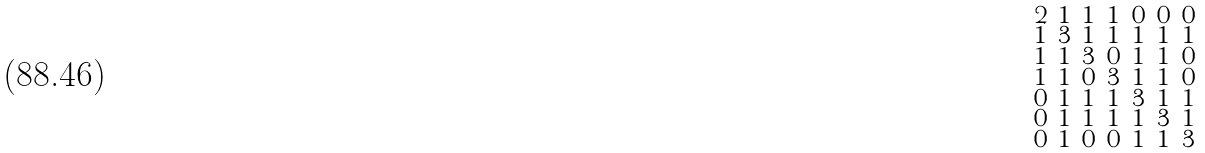Convert formula to latex. <formula><loc_0><loc_0><loc_500><loc_500>\begin{smallmatrix} 2 & 1 & 1 & 1 & 0 & 0 & 0 \\ 1 & 3 & 1 & 1 & 1 & 1 & 1 \\ 1 & 1 & 3 & 0 & 1 & 1 & 0 \\ 1 & 1 & 0 & 3 & 1 & 1 & 0 \\ 0 & 1 & 1 & 1 & 3 & 1 & 1 \\ 0 & 1 & 1 & 1 & 1 & 3 & 1 \\ 0 & 1 & 0 & 0 & 1 & 1 & 3 \end{smallmatrix}</formula> 